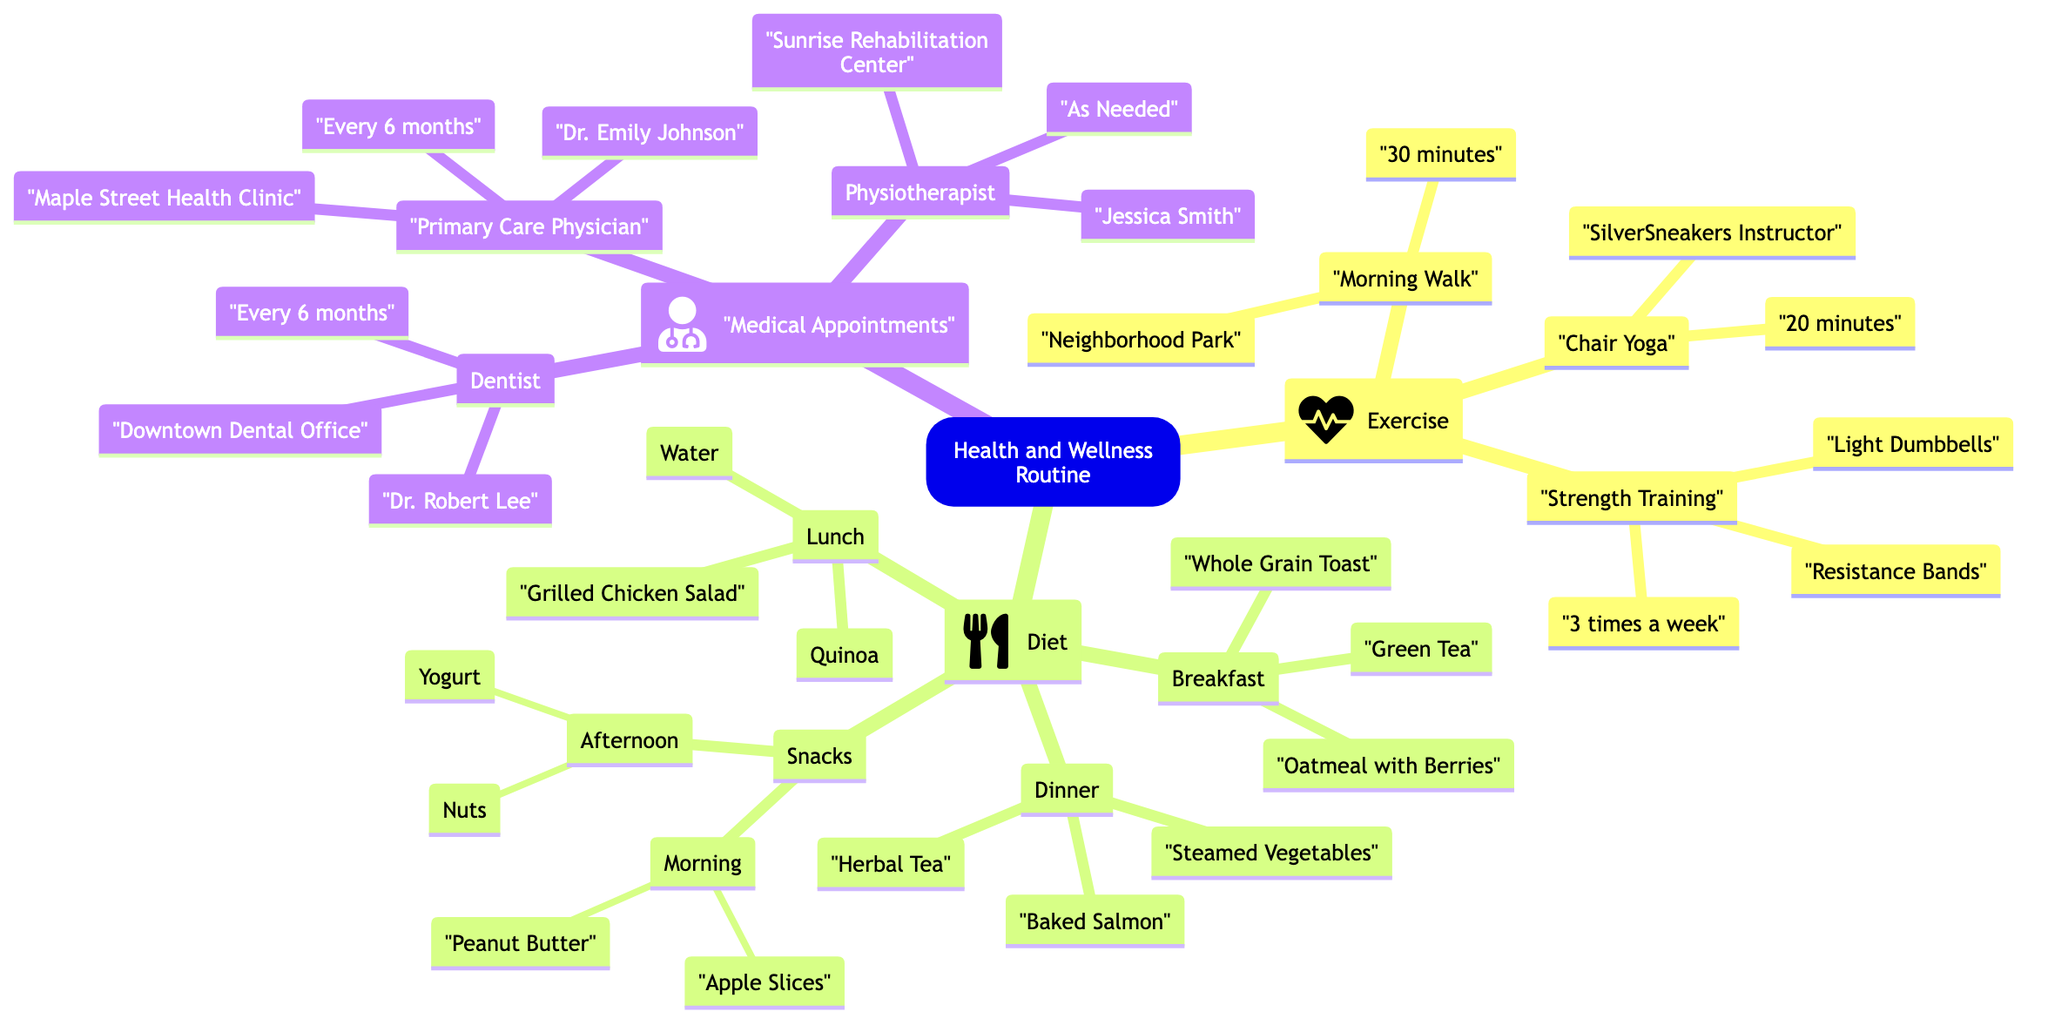What is the duration of the Morning Walk? The duration of the Morning Walk is directly stated in the diagram as "30 minutes." It is specifically listed under the Exercise section associated with Morning Walk.
Answer: 30 minutes How often do you see the Primary Care Physician? The frequency of seeing the Primary Care Physician, Dr. Emily Johnson, is mentioned as "Every 6 months" in the Medical Appointments section of the diagram.
Answer: Every 6 months What are the tools used for Strength Training? The tools for Strength Training are listed as "Resistance Bands" and "Light Dumbbells" in the Exercise section. They are specifically noted under the Strength Training category within the Exercise node.
Answer: Resistance Bands, Light Dumbbells How many types of meals are included in the Diet section? The Diet section includes four types of meals: Breakfast, Lunch, Dinner, and Snacks. This is evident from the listed nodes under the Diet category in the diagram.
Answer: 4 What is the location of the Dentist's office? The location for the Dentist, Dr. Robert Lee, is specified as "Downtown Dental Office" in the Medical Appointments section. It is directly associated with this Dentist node.
Answer: Downtown Dental Office Which beverage is served with Lunch? The beverage served with Lunch is indicated as "Water." This information is found in the Lunch category under the Diet section of the diagram.
Answer: Water How many instructors are mentioned in the Exercise section? The diagram specifies one instructor, "SilverSneakers," associated with the Chair Yoga activity in the Exercise section. Therefore, the total number of instructors is one.
Answer: 1 What types of snacks are included in the Morning? The types of snacks listed for the Morning are "Apple Slices" and "Peanut Butter." This information is found under the Snacks category within the Diet section of the diagram.
Answer: Apple Slices, Peanut Butter What is the frequency for seeing the Physiotherapist? The frequency of visits to the Physiotherapist, Jessica Smith, is noted as "As Needed," which indicates that it is not on a fixed schedule. This is found in the Medical Appointments section.
Answer: As Needed 